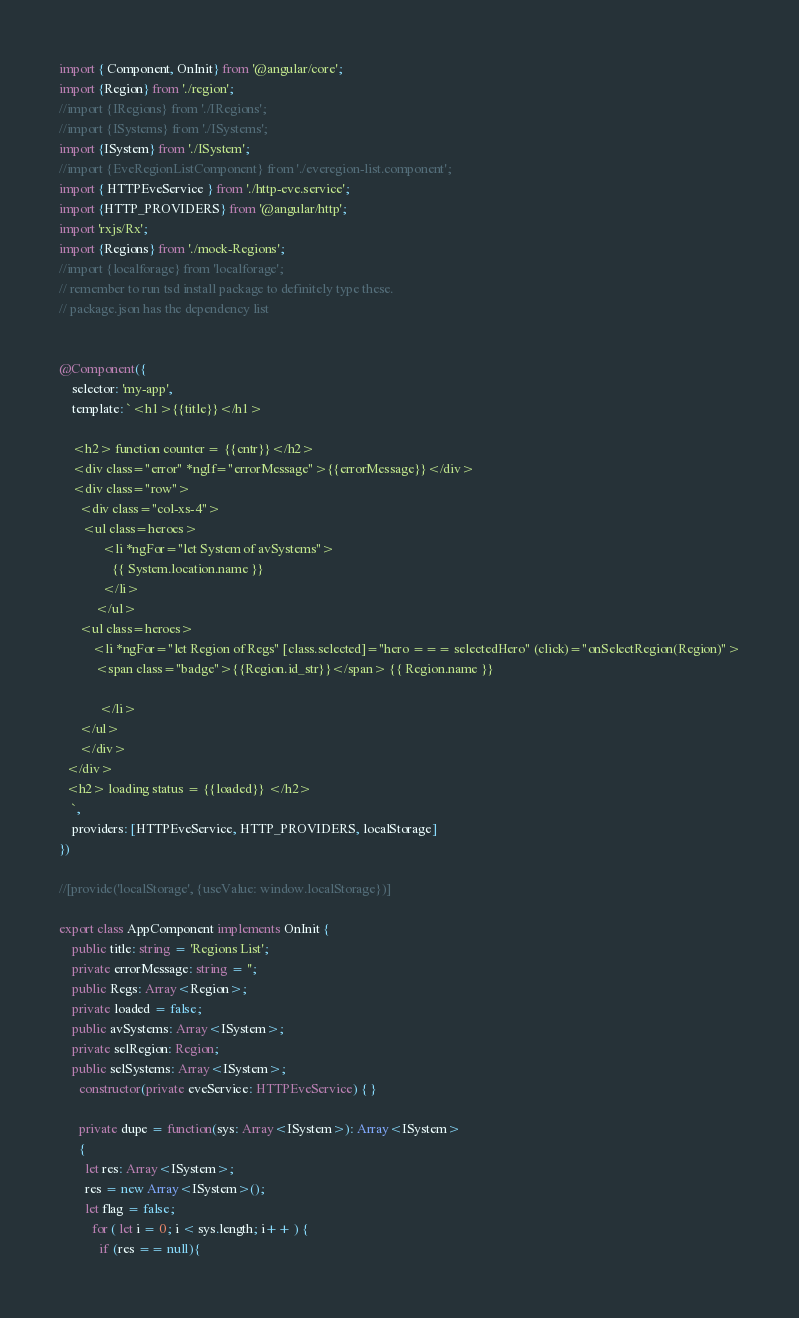Convert code to text. <code><loc_0><loc_0><loc_500><loc_500><_TypeScript_>import { Component, OnInit} from '@angular/core';
import {Region} from './region';
//import {IRegions} from './IRegions';
//import {ISystems} from './ISystems';
import {ISystem} from './ISystem';
//import {EveRegionListComponent} from './everegion-list.component';
import { HTTPEveService } from './http-eve.service';
import {HTTP_PROVIDERS} from '@angular/http';
import 'rxjs/Rx';
import {Regions} from './mock-Regions';
//import {localforage} from 'localforage';
// remember to run tsd install package to definitely type these.
// package.json has the dependency list


@Component({
    selector: 'my-app',
    template: `<h1>{{title}}</h1>
    
    <h2> function counter = {{cntr}}</h2>
    <div class="error" *ngIf="errorMessage">{{errorMessage}}</div>
    <div class="row">
      <div class="col-xs-4">
       <ul class=heroes>
             <li *ngFor="let System of avSystems">
                {{ System.location.name }} 
             </li>
           </ul>
      <ul class=heroes>
          <li *ngFor="let Region of Regs" [class.selected]="hero === selectedHero" (click)="onSelectRegion(Region)">
           <span class="badge">{{Region.id_str}}</span> {{ Region.name }}
          
            </li>
      </ul>
      </div>
  </div>
  <h2> loading status = {{loaded}} </h2>
    `,
    providers: [HTTPEveService, HTTP_PROVIDERS, localStorage]
})

//[provide('localStorage', {useValue: window.localStorage})]

export class AppComponent implements OnInit {
    public title: string = 'Regions List';
    private errorMessage: string = '';
    public Regs: Array<Region>;
    private loaded = false;
    public avSystems: Array<ISystem>;
    private selRegion: Region;
    public selSystems: Array<ISystem>;
      constructor(private eveService: HTTPEveService) { }
      
      private dupe = function(sys: Array<ISystem>): Array<ISystem>
      {
        let res: Array<ISystem>;
        res = new Array<ISystem>();
        let flag = false;
          for ( let i = 0; i < sys.length; i++ ) {
            if (res == null){</code> 